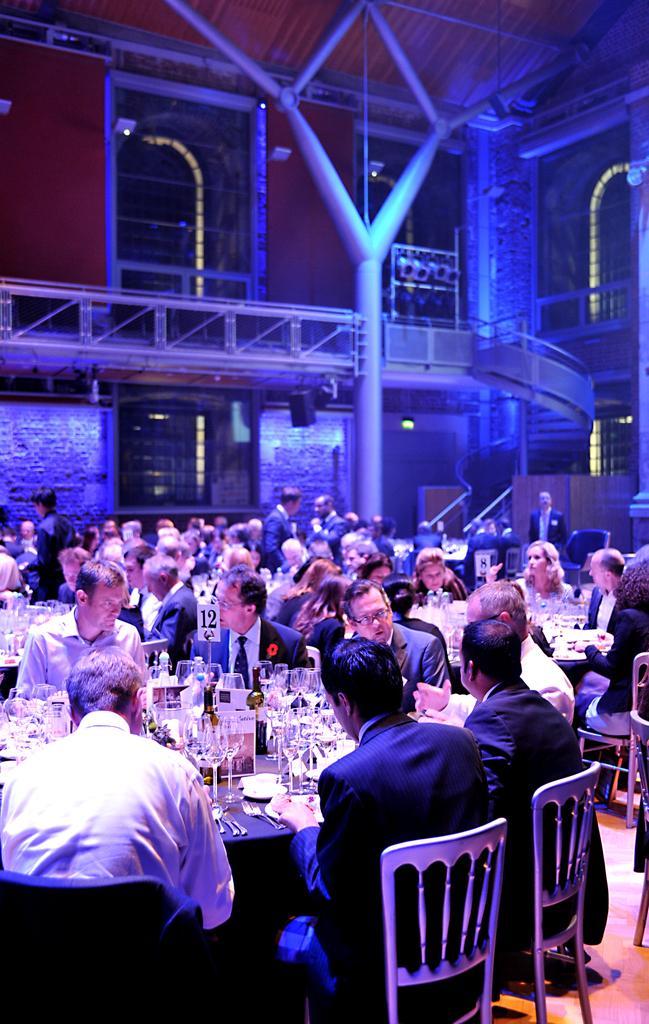Describe this image in one or two sentences. In this picture there are people sitting in a round table and with food items on top of it which include glasses , in the background there are stairs to the above floor and glass doors. 